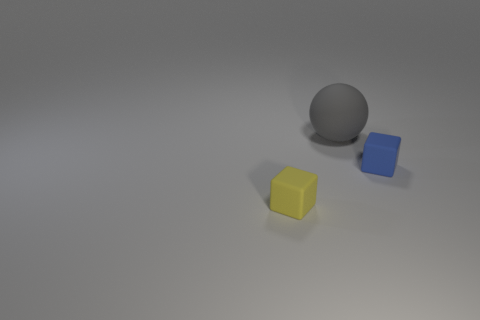Add 1 blue rubber cubes. How many objects exist? 4 Subtract all balls. How many objects are left? 2 Subtract 0 green cylinders. How many objects are left? 3 Subtract all balls. Subtract all rubber spheres. How many objects are left? 1 Add 1 tiny blue cubes. How many tiny blue cubes are left? 2 Add 1 purple spheres. How many purple spheres exist? 1 